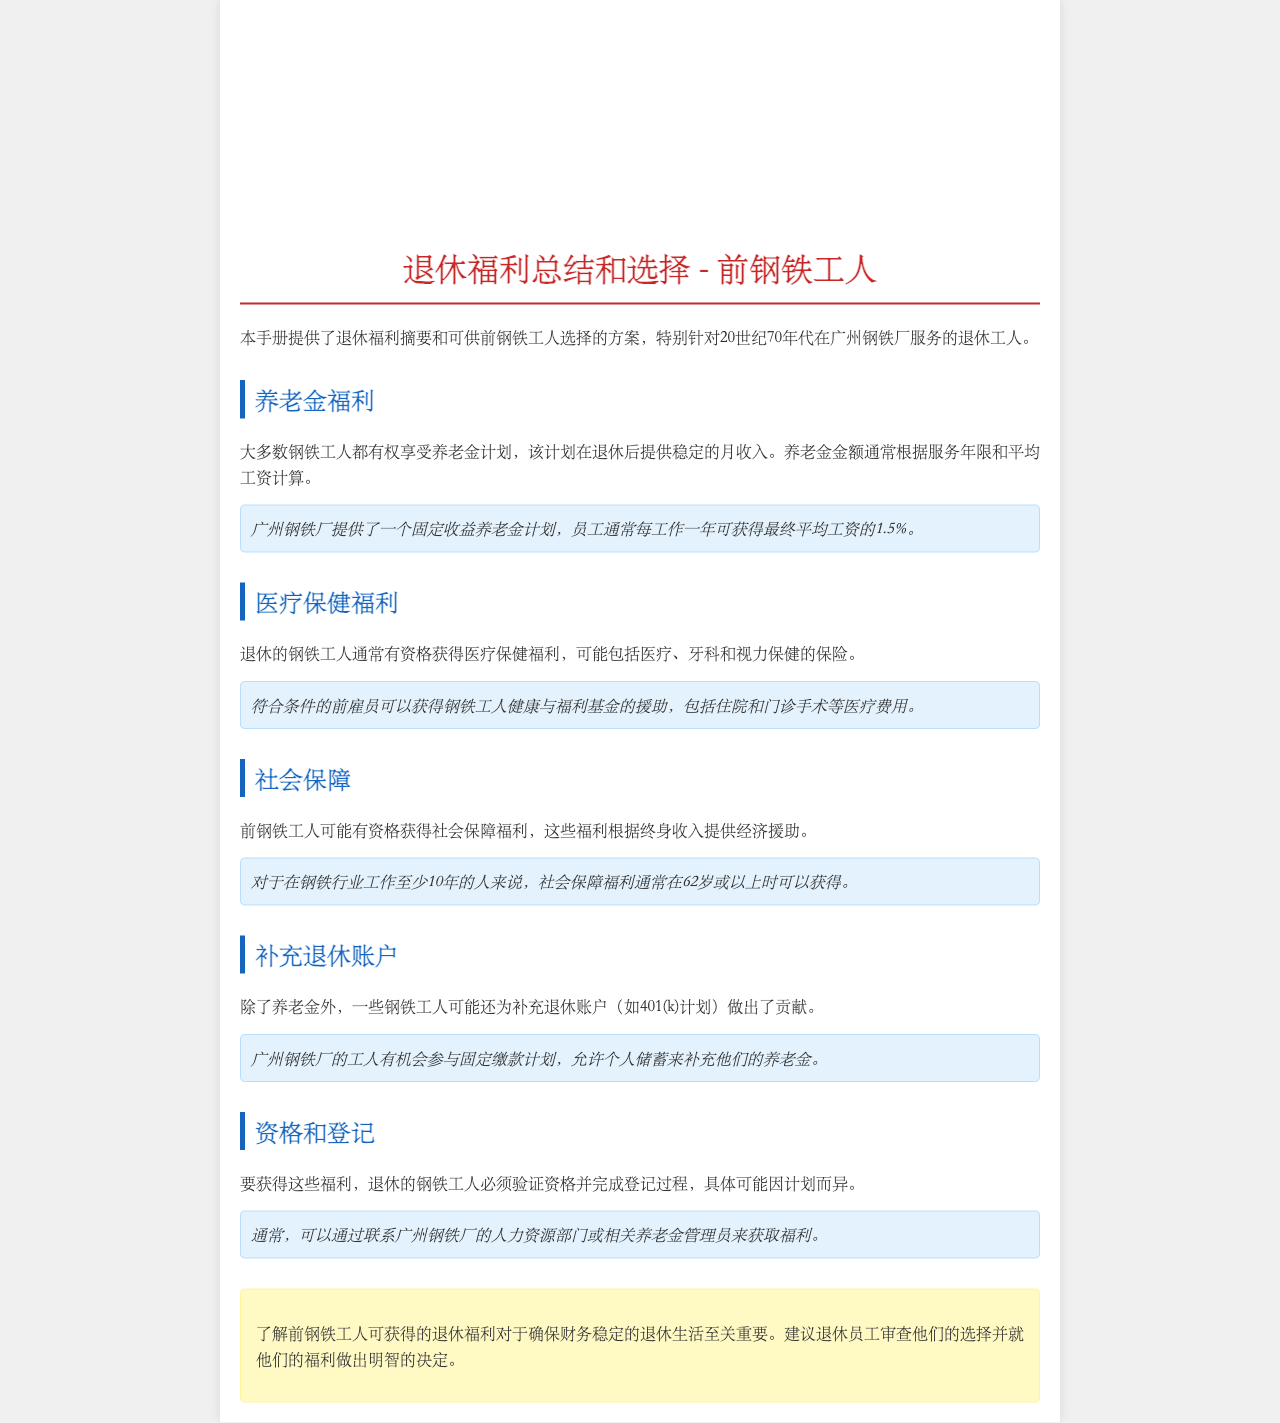What is the primary purpose of the manual? The manual provides a summary of retirement benefits and options for former steelworkers, specifically those who worked in the 1970s at the Guangzhou Steel Plant.
Answer: 退休福利总结和选择 What is the formula for calculating pension amounts? The pension amount is generally calculated based on years of service and average salary.
Answer: 服务年限和平均工资 What percentage of the final average salary do workers earn per year of service? Workers typically receive 1.5% of their final average salary for each year worked.
Answer: 1.5% What healthcare services are covered under the benefits? The benefits may include medical, dental, and vision care insurance.
Answer: 医疗、牙科和视力保健 How long must a worker be employed in the steel industry to qualify for social security benefits? Workers must have at least 10 years of service in the steel industry to qualify for social security benefits.
Answer: 10年 What type of retirement accounts might steelworkers have contributed to? Steelworkers may have contributed to supplemental retirement accounts like 401(k) plans.
Answer: 401(k)计划 What must former steelworkers do to access their benefits? Retired steelworkers must verify eligibility and complete the registration process to access their benefits.
Answer: 验证资格和完成登记 Who can provide assistance regarding the benefits? Assistance can usually be obtained by contacting the human resources department of the Guangzhou Steel Plant or related pension administrators.
Answer: 人力资源部门或养老金管理员 